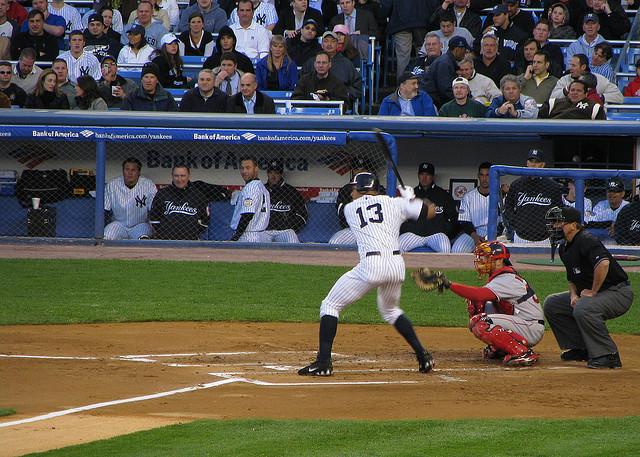How many people in this shot?
Keep it brief. 40. What is the title of the man wearing red?
Write a very short answer. Catcher. What is the number of the batter?
Give a very brief answer. 13. What time of day is it?
Quick response, please. Afternoon. What color shirt is the batter wearing?
Answer briefly. White. What color are the rails?
Concise answer only. Blue. Is the batter batting right or left handed?
Be succinct. Right. Which team is at bat?
Be succinct. Yankees. What number is the batter?
Write a very short answer. 13. What game is being played?
Concise answer only. Baseball. Is the batter left handed?
Quick response, please. No. Is the batter right or left handed?
Keep it brief. Right. Who is the batter?
Keep it brief. 13. 